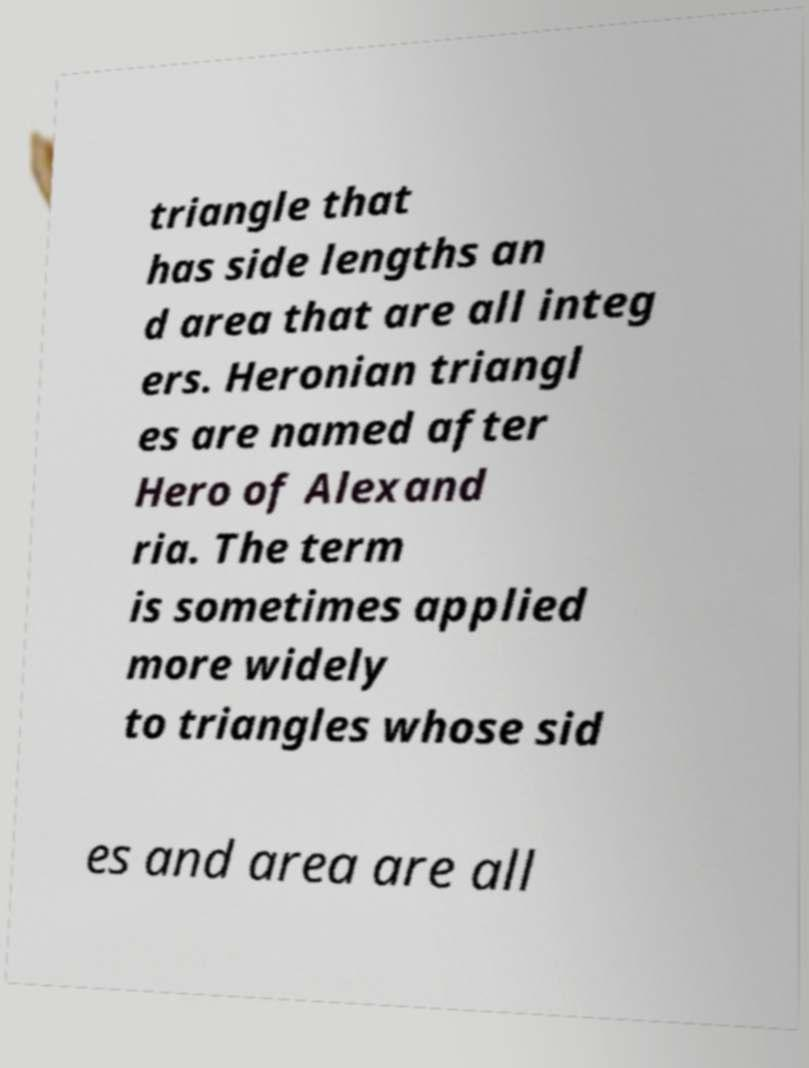What messages or text are displayed in this image? I need them in a readable, typed format. triangle that has side lengths an d area that are all integ ers. Heronian triangl es are named after Hero of Alexand ria. The term is sometimes applied more widely to triangles whose sid es and area are all 